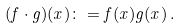<formula> <loc_0><loc_0><loc_500><loc_500>( f \cdot g ) ( x ) \colon = f ( x ) g ( x ) \, .</formula> 